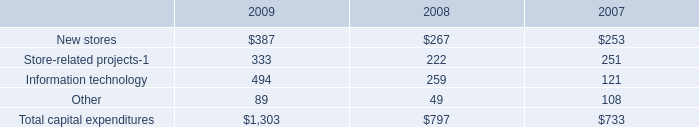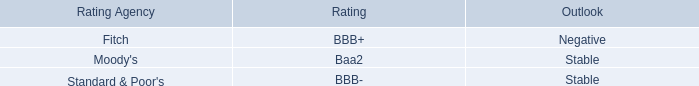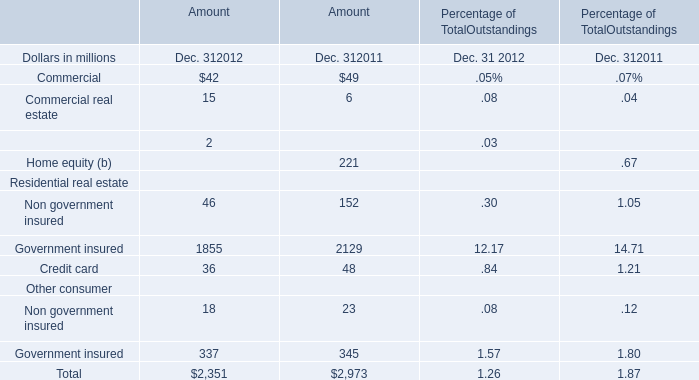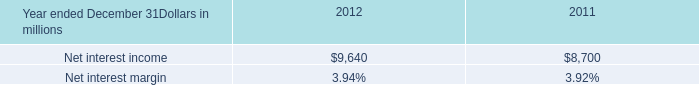what was the change in net interest margin between 2012 and 2011.? 
Computations: (3.94 - 3.92)
Answer: 0.02. 